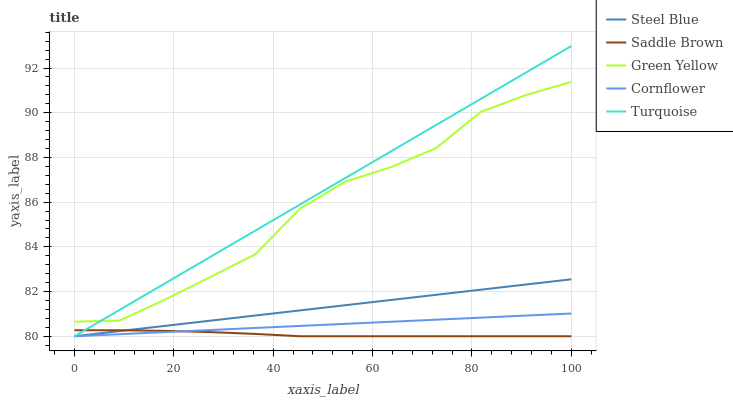Does Saddle Brown have the minimum area under the curve?
Answer yes or no. Yes. Does Turquoise have the maximum area under the curve?
Answer yes or no. Yes. Does Green Yellow have the minimum area under the curve?
Answer yes or no. No. Does Green Yellow have the maximum area under the curve?
Answer yes or no. No. Is Turquoise the smoothest?
Answer yes or no. Yes. Is Green Yellow the roughest?
Answer yes or no. Yes. Is Green Yellow the smoothest?
Answer yes or no. No. Is Turquoise the roughest?
Answer yes or no. No. Does Cornflower have the lowest value?
Answer yes or no. Yes. Does Green Yellow have the lowest value?
Answer yes or no. No. Does Turquoise have the highest value?
Answer yes or no. Yes. Does Green Yellow have the highest value?
Answer yes or no. No. Is Cornflower less than Green Yellow?
Answer yes or no. Yes. Is Green Yellow greater than Saddle Brown?
Answer yes or no. Yes. Does Turquoise intersect Cornflower?
Answer yes or no. Yes. Is Turquoise less than Cornflower?
Answer yes or no. No. Is Turquoise greater than Cornflower?
Answer yes or no. No. Does Cornflower intersect Green Yellow?
Answer yes or no. No. 